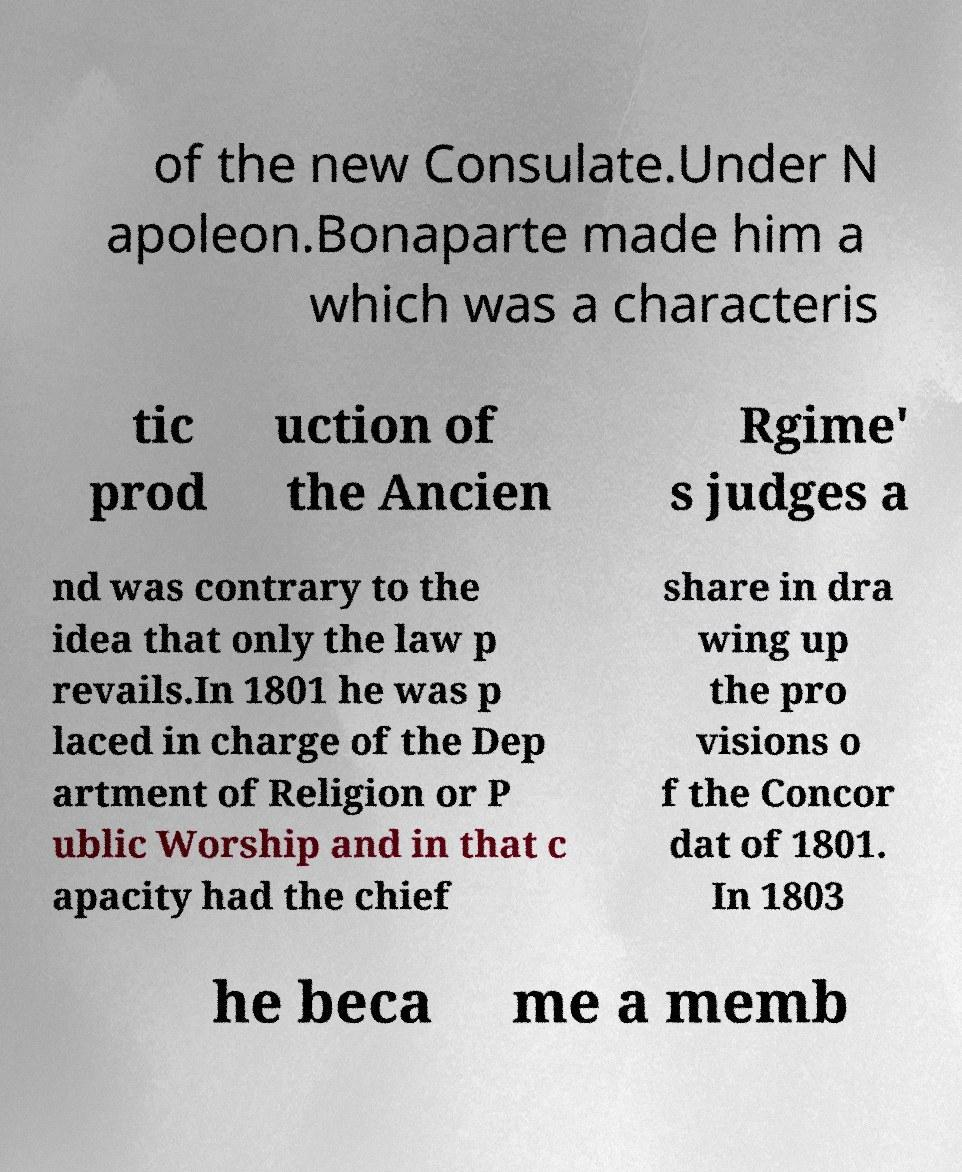Can you accurately transcribe the text from the provided image for me? of the new Consulate.Under N apoleon.Bonaparte made him a which was a characteris tic prod uction of the Ancien Rgime' s judges a nd was contrary to the idea that only the law p revails.In 1801 he was p laced in charge of the Dep artment of Religion or P ublic Worship and in that c apacity had the chief share in dra wing up the pro visions o f the Concor dat of 1801. In 1803 he beca me a memb 